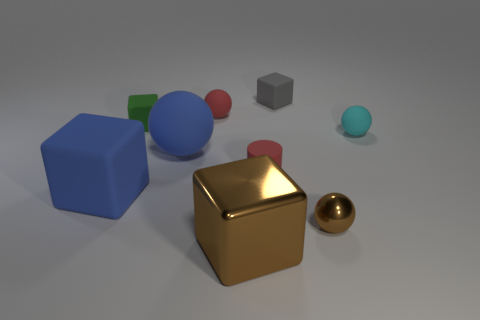Are there any gray objects that have the same size as the green matte block?
Make the answer very short. Yes. There is a gray block that is the same size as the brown metallic ball; what material is it?
Your response must be concise. Rubber. What shape is the small matte thing that is in front of the small green matte object and behind the small cylinder?
Provide a succinct answer. Sphere. What is the color of the tiny matte object to the right of the small brown metallic sphere?
Your response must be concise. Cyan. There is a rubber ball that is on the left side of the cyan ball and in front of the small green thing; what is its size?
Offer a very short reply. Large. Is the red cylinder made of the same material as the sphere in front of the tiny matte cylinder?
Make the answer very short. No. How many other tiny cyan things have the same shape as the cyan rubber thing?
Provide a short and direct response. 0. There is a object that is the same color as the small shiny ball; what is its material?
Your answer should be compact. Metal. How many purple rubber blocks are there?
Your answer should be very brief. 0. Is the shape of the small green object the same as the blue matte object that is on the right side of the green thing?
Give a very brief answer. No. 